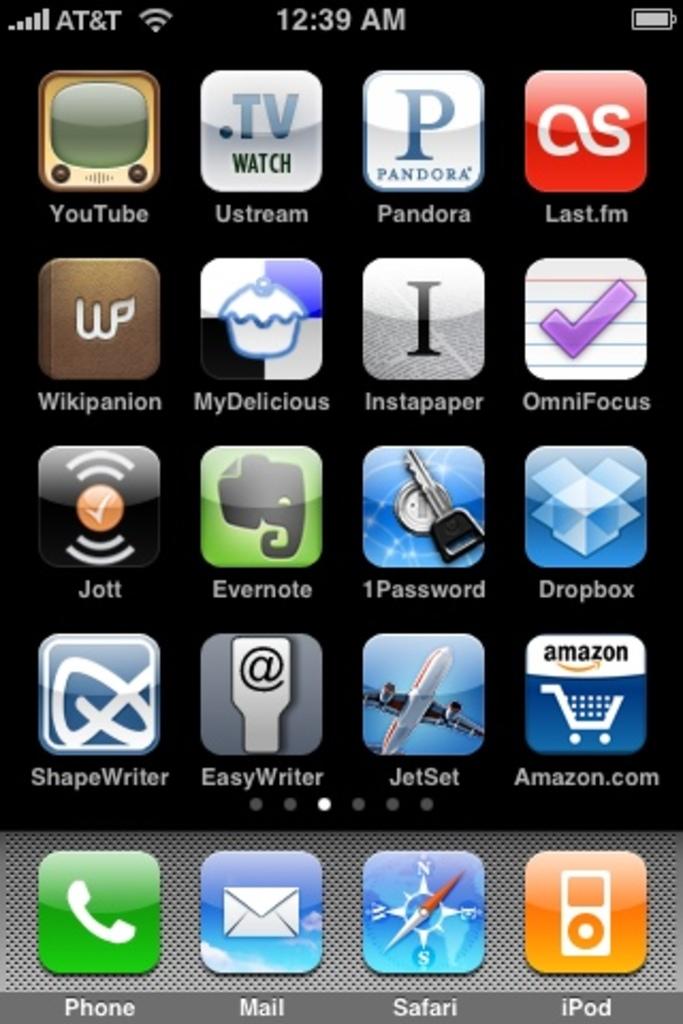What time is displayed?
Offer a very short reply. 12:39. 